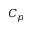<formula> <loc_0><loc_0><loc_500><loc_500>C _ { p }</formula> 